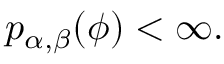<formula> <loc_0><loc_0><loc_500><loc_500>p _ { \alpha , \beta } ( \phi ) < \infty .</formula> 